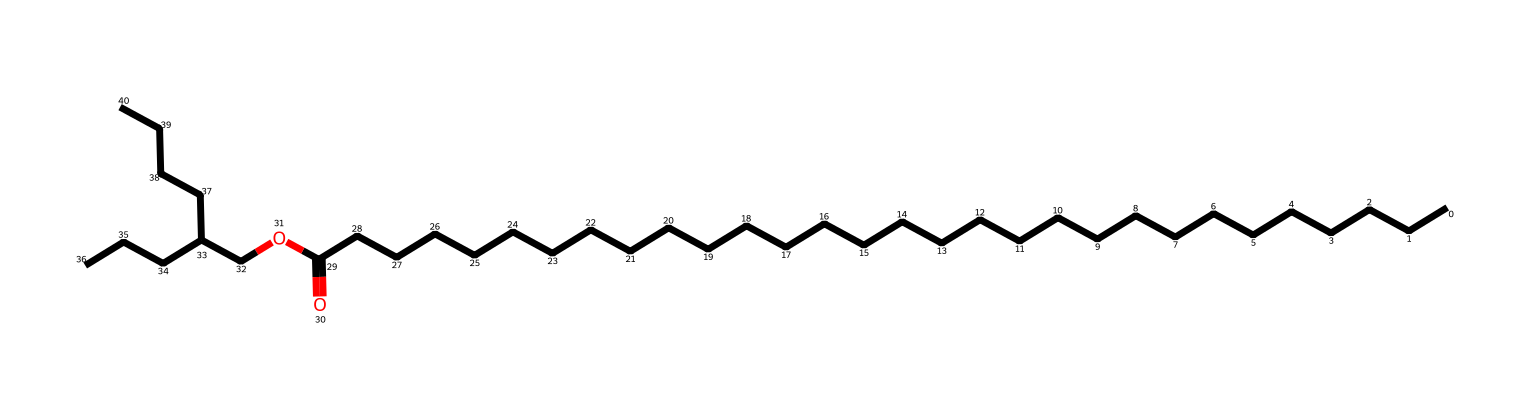What is the main functional group present in this compound? The compound contains an ester functional group, which can be identified by the presence of the carbonyl group (C=O) adjacent to an oxygen atom that is part of an ether-like structure (O-R).
Answer: ester How many carbon atoms are in the molecular structure? By analyzing the SMILES representation, we can count the number of carbons. There are 27 carbon atoms indicated in the long alkane chains and branching in the structure.
Answer: 27 What type of bond connects the carbonyl carbon to the oxygen in the ester group? In the ester functional group, the carbonyl carbon is connected to the oxygen by a single sigma bond, which is characteristic of esters. This can be inferred from the structure as a C-O bond following the carbonyl (C=O).
Answer: single bond What is the total number of oxygen atoms in this compound? The compound contains two oxygen atoms: one in the carbonyl group and one in the ester linkage. This can be confirmed by identifying the two O atoms present in the SMILES representation.
Answer: 2 Is this compound more likely to be soluble in water or in organic solvents? Given the long hydrocarbon chains in the structure, this ether is more hydrophobic and has a greater tendency to dissolve in organic solvents than in water. This is due to the nonpolar character of the alkyl groups overwhelming the polar character of the ester linkage.
Answer: organic solvents What type of chemical is this compound classified as based on its functional group? This compound is specifically classified as an ether based on the presence of the ether-like oxygen linkage (connected to carbon chains) and the characteristics of its structure.
Answer: ether 